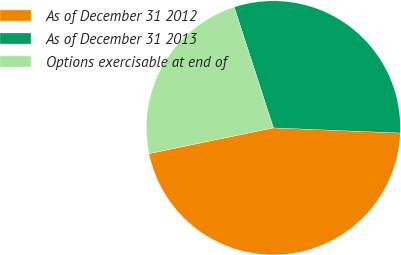Convert chart. <chart><loc_0><loc_0><loc_500><loc_500><pie_chart><fcel>As of December 31 2012<fcel>As of December 31 2013<fcel>Options exercisable at end of<nl><fcel>46.11%<fcel>30.64%<fcel>23.25%<nl></chart> 